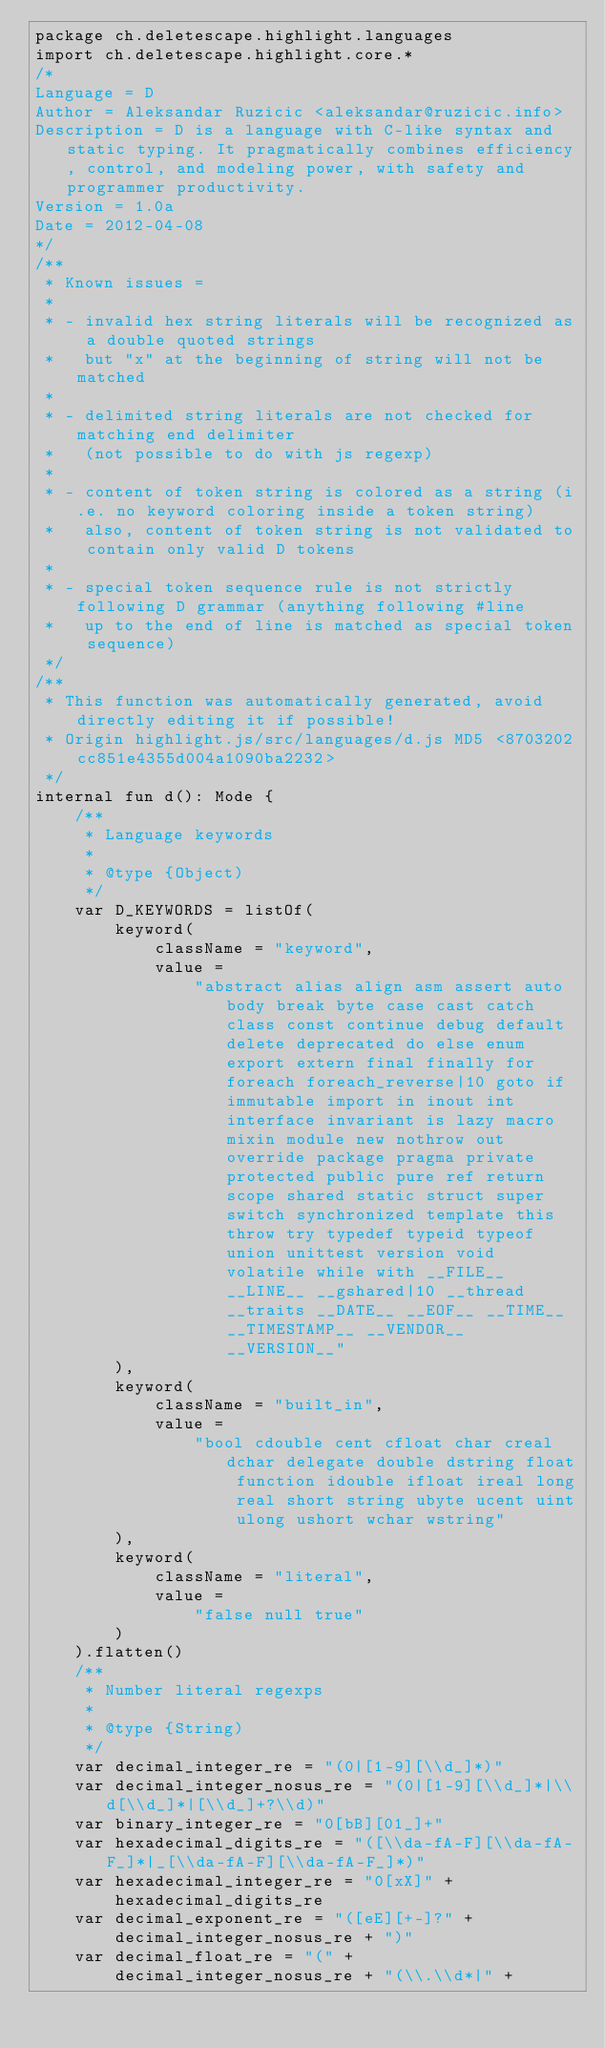<code> <loc_0><loc_0><loc_500><loc_500><_Kotlin_>package ch.deletescape.highlight.languages
import ch.deletescape.highlight.core.*
/*
Language = D
Author = Aleksandar Ruzicic <aleksandar@ruzicic.info>
Description = D is a language with C-like syntax and static typing. It pragmatically combines efficiency, control, and modeling power, with safety and programmer productivity.
Version = 1.0a
Date = 2012-04-08
*/
/**
 * Known issues =
 *
 * - invalid hex string literals will be recognized as a double quoted strings
 *   but "x" at the beginning of string will not be matched
 *
 * - delimited string literals are not checked for matching end delimiter
 *   (not possible to do with js regexp)
 *
 * - content of token string is colored as a string (i.e. no keyword coloring inside a token string)
 *   also, content of token string is not validated to contain only valid D tokens
 *
 * - special token sequence rule is not strictly following D grammar (anything following #line
 *   up to the end of line is matched as special token sequence)
 */
/**
 * This function was automatically generated, avoid directly editing it if possible!
 * Origin highlight.js/src/languages/d.js MD5 <8703202cc851e4355d004a1090ba2232>
 */
internal fun d(): Mode {
    /**
     * Language keywords
     *
     * @type {Object)
     */
    var D_KEYWORDS = listOf(
        keyword(
            className = "keyword",
            value =
                "abstract alias align asm assert auto body break byte case cast catch class const continue debug default delete deprecated do else enum export extern final finally for foreach foreach_reverse|10 goto if immutable import in inout int interface invariant is lazy macro mixin module new nothrow out override package pragma private protected public pure ref return scope shared static struct super switch synchronized template this throw try typedef typeid typeof union unittest version void volatile while with __FILE__ __LINE__ __gshared|10 __thread __traits __DATE__ __EOF__ __TIME__ __TIMESTAMP__ __VENDOR__ __VERSION__"
        ),
        keyword(
            className = "built_in",
            value =
                "bool cdouble cent cfloat char creal dchar delegate double dstring float function idouble ifloat ireal long real short string ubyte ucent uint ulong ushort wchar wstring"
        ),
        keyword(
            className = "literal",
            value =
                "false null true"
        )
    ).flatten()
    /**
     * Number literal regexps
     *
     * @type {String)
     */
    var decimal_integer_re = "(0|[1-9][\\d_]*)"
    var decimal_integer_nosus_re = "(0|[1-9][\\d_]*|\\d[\\d_]*|[\\d_]+?\\d)"
    var binary_integer_re = "0[bB][01_]+"
    var hexadecimal_digits_re = "([\\da-fA-F][\\da-fA-F_]*|_[\\da-fA-F][\\da-fA-F_]*)"
    var hexadecimal_integer_re = "0[xX]" +
        hexadecimal_digits_re
    var decimal_exponent_re = "([eE][+-]?" +
        decimal_integer_nosus_re + ")"
    var decimal_float_re = "(" +
        decimal_integer_nosus_re + "(\\.\\d*|" +</code> 